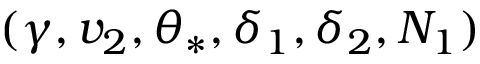<formula> <loc_0><loc_0><loc_500><loc_500>( \gamma , v _ { 2 } , \theta _ { \ast } , \delta _ { 1 } , \delta _ { 2 } , N _ { 1 } )</formula> 